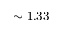<formula> <loc_0><loc_0><loc_500><loc_500>\sim 1 . 3 3</formula> 